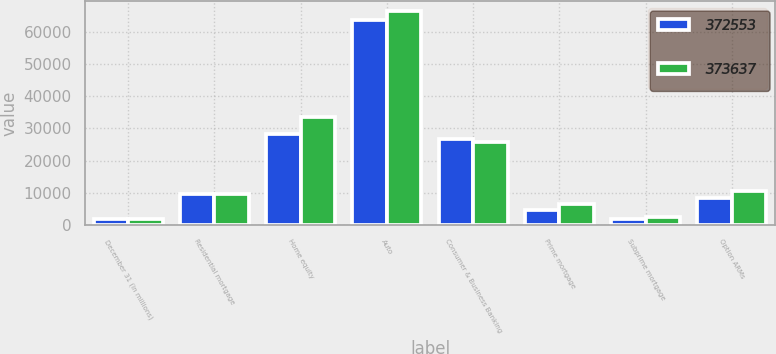<chart> <loc_0><loc_0><loc_500><loc_500><stacked_bar_chart><ecel><fcel>December 31 (in millions)<fcel>Residential mortgage<fcel>Home equity<fcel>Auto<fcel>Consumer & Business Banking<fcel>Prime mortgage<fcel>Subprime mortgage<fcel>Option ARMs<nl><fcel>372553<fcel>2018<fcel>9562.5<fcel>28340<fcel>63573<fcel>26612<fcel>4690<fcel>1945<fcel>8436<nl><fcel>373637<fcel>2017<fcel>9562.5<fcel>33450<fcel>66242<fcel>25789<fcel>6479<fcel>2609<fcel>10689<nl></chart> 